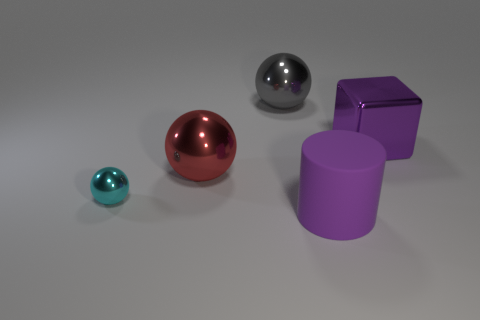Add 2 large gray balls. How many objects exist? 7 Subtract all large balls. How many balls are left? 1 Subtract all red spheres. How many spheres are left? 2 Subtract 1 balls. How many balls are left? 2 Add 4 cyan balls. How many cyan balls are left? 5 Add 2 red shiny things. How many red shiny things exist? 3 Subtract 0 cyan cubes. How many objects are left? 5 Subtract all spheres. How many objects are left? 2 Subtract all green cylinders. Subtract all blue blocks. How many cylinders are left? 1 Subtract all gray balls. How many red cubes are left? 0 